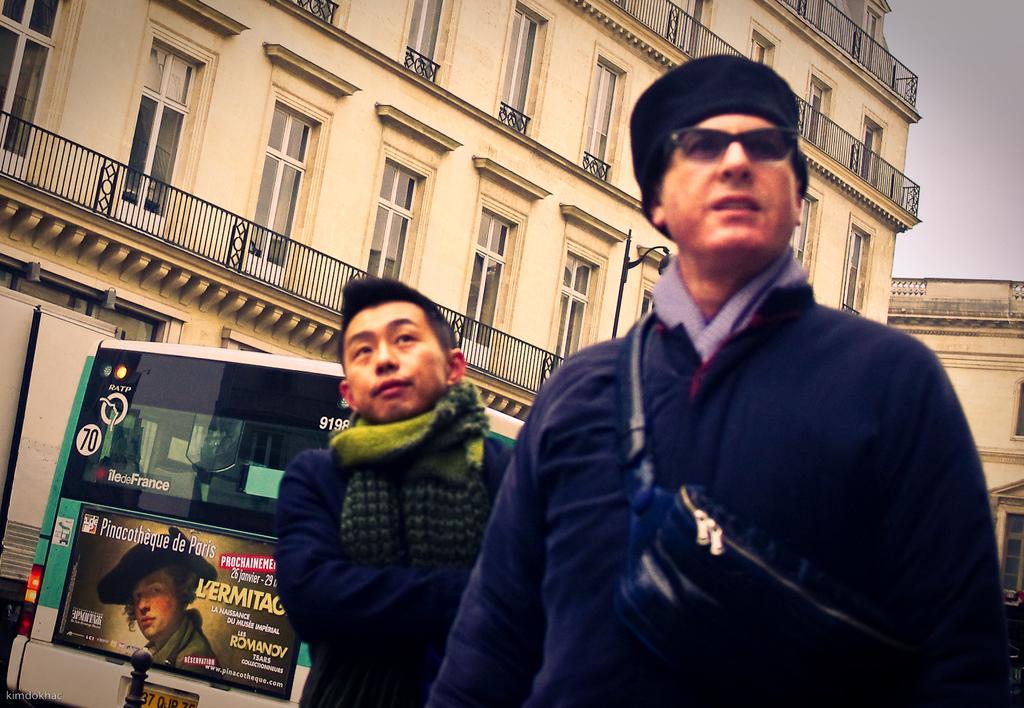Can you describe this image briefly? In the foreground of the image there are two people. There is a bus with a poster on it. In the background of the image there are buildings with windows and railing. At the top of the image there is sky. 